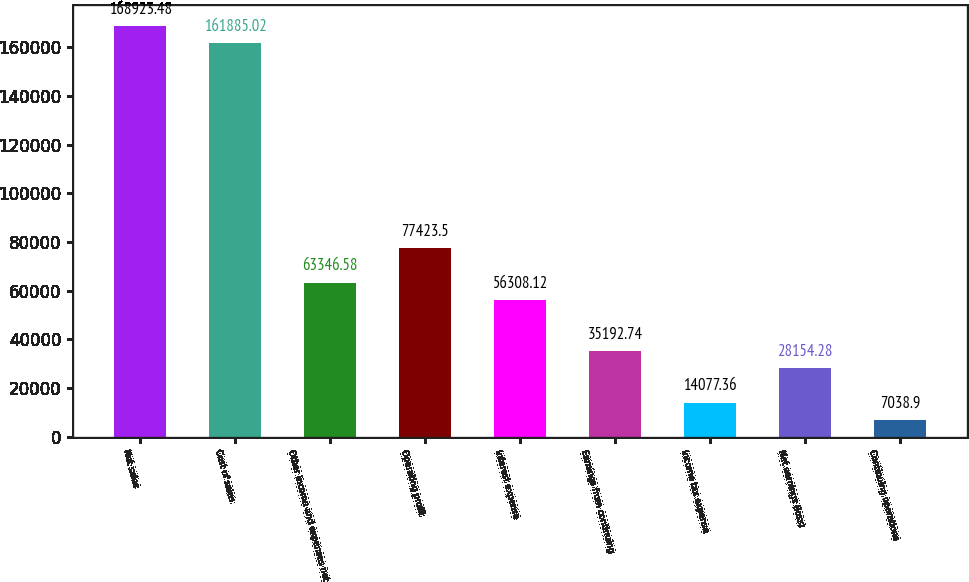Convert chart. <chart><loc_0><loc_0><loc_500><loc_500><bar_chart><fcel>Net sales<fcel>Cost of sales<fcel>Other income and expenses net<fcel>Operating profit<fcel>Interest expense<fcel>Earnings from continuing<fcel>Income tax expense<fcel>Net earnings (loss)<fcel>Continuing operations<nl><fcel>168923<fcel>161885<fcel>63346.6<fcel>77423.5<fcel>56308.1<fcel>35192.7<fcel>14077.4<fcel>28154.3<fcel>7038.9<nl></chart> 